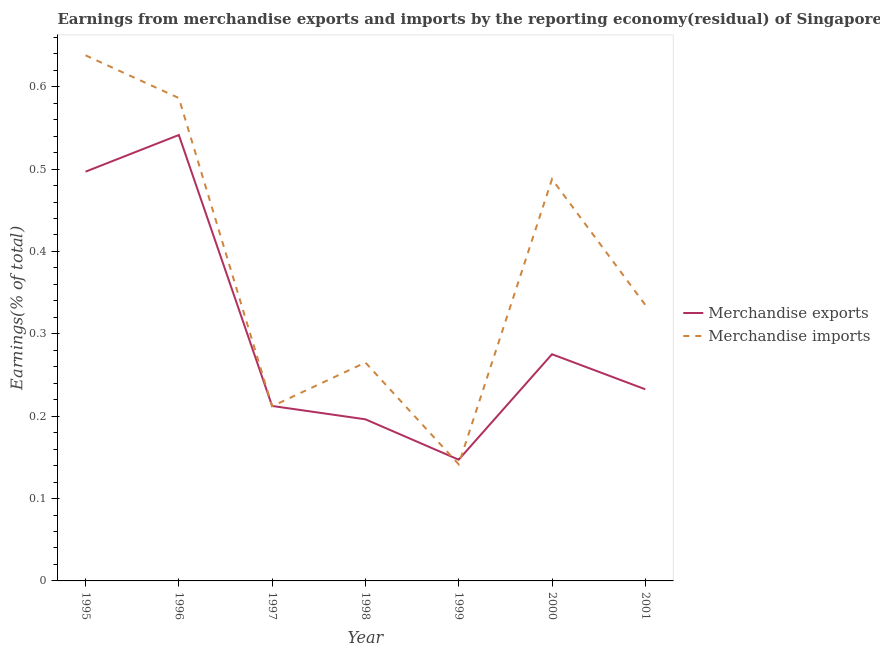How many different coloured lines are there?
Make the answer very short. 2. Does the line corresponding to earnings from merchandise imports intersect with the line corresponding to earnings from merchandise exports?
Give a very brief answer. Yes. Is the number of lines equal to the number of legend labels?
Keep it short and to the point. Yes. What is the earnings from merchandise imports in 2001?
Make the answer very short. 0.34. Across all years, what is the maximum earnings from merchandise exports?
Provide a short and direct response. 0.54. Across all years, what is the minimum earnings from merchandise imports?
Provide a short and direct response. 0.14. What is the total earnings from merchandise exports in the graph?
Make the answer very short. 2.1. What is the difference between the earnings from merchandise exports in 1998 and that in 2000?
Provide a succinct answer. -0.08. What is the difference between the earnings from merchandise exports in 1997 and the earnings from merchandise imports in 1996?
Provide a short and direct response. -0.37. What is the average earnings from merchandise exports per year?
Provide a succinct answer. 0.3. In the year 1996, what is the difference between the earnings from merchandise exports and earnings from merchandise imports?
Your answer should be very brief. -0.04. What is the ratio of the earnings from merchandise imports in 1996 to that in 2000?
Ensure brevity in your answer.  1.2. Is the difference between the earnings from merchandise exports in 1996 and 1998 greater than the difference between the earnings from merchandise imports in 1996 and 1998?
Your answer should be very brief. Yes. What is the difference between the highest and the second highest earnings from merchandise exports?
Provide a short and direct response. 0.04. What is the difference between the highest and the lowest earnings from merchandise imports?
Provide a short and direct response. 0.5. Is the sum of the earnings from merchandise imports in 1995 and 1997 greater than the maximum earnings from merchandise exports across all years?
Offer a terse response. Yes. Does the earnings from merchandise imports monotonically increase over the years?
Ensure brevity in your answer.  No. Is the earnings from merchandise exports strictly greater than the earnings from merchandise imports over the years?
Give a very brief answer. No. How many lines are there?
Give a very brief answer. 2. Are the values on the major ticks of Y-axis written in scientific E-notation?
Offer a terse response. No. Where does the legend appear in the graph?
Provide a short and direct response. Center right. How many legend labels are there?
Your answer should be compact. 2. How are the legend labels stacked?
Your response must be concise. Vertical. What is the title of the graph?
Give a very brief answer. Earnings from merchandise exports and imports by the reporting economy(residual) of Singapore. Does "From production" appear as one of the legend labels in the graph?
Keep it short and to the point. No. What is the label or title of the X-axis?
Your answer should be compact. Year. What is the label or title of the Y-axis?
Provide a succinct answer. Earnings(% of total). What is the Earnings(% of total) of Merchandise exports in 1995?
Offer a terse response. 0.5. What is the Earnings(% of total) in Merchandise imports in 1995?
Give a very brief answer. 0.64. What is the Earnings(% of total) in Merchandise exports in 1996?
Offer a terse response. 0.54. What is the Earnings(% of total) in Merchandise imports in 1996?
Offer a very short reply. 0.59. What is the Earnings(% of total) in Merchandise exports in 1997?
Keep it short and to the point. 0.21. What is the Earnings(% of total) in Merchandise imports in 1997?
Your answer should be compact. 0.21. What is the Earnings(% of total) in Merchandise exports in 1998?
Offer a very short reply. 0.2. What is the Earnings(% of total) in Merchandise imports in 1998?
Provide a short and direct response. 0.27. What is the Earnings(% of total) in Merchandise exports in 1999?
Your answer should be very brief. 0.15. What is the Earnings(% of total) in Merchandise imports in 1999?
Your response must be concise. 0.14. What is the Earnings(% of total) of Merchandise exports in 2000?
Keep it short and to the point. 0.28. What is the Earnings(% of total) in Merchandise imports in 2000?
Your response must be concise. 0.49. What is the Earnings(% of total) of Merchandise exports in 2001?
Offer a terse response. 0.23. What is the Earnings(% of total) of Merchandise imports in 2001?
Provide a short and direct response. 0.34. Across all years, what is the maximum Earnings(% of total) of Merchandise exports?
Ensure brevity in your answer.  0.54. Across all years, what is the maximum Earnings(% of total) in Merchandise imports?
Keep it short and to the point. 0.64. Across all years, what is the minimum Earnings(% of total) of Merchandise exports?
Offer a very short reply. 0.15. Across all years, what is the minimum Earnings(% of total) in Merchandise imports?
Ensure brevity in your answer.  0.14. What is the total Earnings(% of total) of Merchandise exports in the graph?
Provide a succinct answer. 2.1. What is the total Earnings(% of total) in Merchandise imports in the graph?
Ensure brevity in your answer.  2.67. What is the difference between the Earnings(% of total) of Merchandise exports in 1995 and that in 1996?
Keep it short and to the point. -0.04. What is the difference between the Earnings(% of total) in Merchandise imports in 1995 and that in 1996?
Ensure brevity in your answer.  0.05. What is the difference between the Earnings(% of total) of Merchandise exports in 1995 and that in 1997?
Offer a terse response. 0.28. What is the difference between the Earnings(% of total) in Merchandise imports in 1995 and that in 1997?
Keep it short and to the point. 0.43. What is the difference between the Earnings(% of total) in Merchandise exports in 1995 and that in 1998?
Your response must be concise. 0.3. What is the difference between the Earnings(% of total) of Merchandise imports in 1995 and that in 1998?
Make the answer very short. 0.37. What is the difference between the Earnings(% of total) of Merchandise exports in 1995 and that in 1999?
Give a very brief answer. 0.35. What is the difference between the Earnings(% of total) of Merchandise imports in 1995 and that in 1999?
Your answer should be compact. 0.5. What is the difference between the Earnings(% of total) in Merchandise exports in 1995 and that in 2000?
Your answer should be compact. 0.22. What is the difference between the Earnings(% of total) of Merchandise imports in 1995 and that in 2000?
Your response must be concise. 0.15. What is the difference between the Earnings(% of total) in Merchandise exports in 1995 and that in 2001?
Your response must be concise. 0.26. What is the difference between the Earnings(% of total) of Merchandise imports in 1995 and that in 2001?
Your answer should be compact. 0.3. What is the difference between the Earnings(% of total) of Merchandise exports in 1996 and that in 1997?
Keep it short and to the point. 0.33. What is the difference between the Earnings(% of total) of Merchandise imports in 1996 and that in 1997?
Your answer should be very brief. 0.37. What is the difference between the Earnings(% of total) of Merchandise exports in 1996 and that in 1998?
Offer a very short reply. 0.35. What is the difference between the Earnings(% of total) of Merchandise imports in 1996 and that in 1998?
Keep it short and to the point. 0.32. What is the difference between the Earnings(% of total) in Merchandise exports in 1996 and that in 1999?
Offer a terse response. 0.39. What is the difference between the Earnings(% of total) of Merchandise imports in 1996 and that in 1999?
Give a very brief answer. 0.44. What is the difference between the Earnings(% of total) of Merchandise exports in 1996 and that in 2000?
Your response must be concise. 0.27. What is the difference between the Earnings(% of total) of Merchandise imports in 1996 and that in 2000?
Your answer should be very brief. 0.1. What is the difference between the Earnings(% of total) in Merchandise exports in 1996 and that in 2001?
Give a very brief answer. 0.31. What is the difference between the Earnings(% of total) of Merchandise imports in 1996 and that in 2001?
Offer a very short reply. 0.25. What is the difference between the Earnings(% of total) in Merchandise exports in 1997 and that in 1998?
Your answer should be compact. 0.02. What is the difference between the Earnings(% of total) of Merchandise imports in 1997 and that in 1998?
Your answer should be very brief. -0.05. What is the difference between the Earnings(% of total) of Merchandise exports in 1997 and that in 1999?
Ensure brevity in your answer.  0.07. What is the difference between the Earnings(% of total) of Merchandise imports in 1997 and that in 1999?
Your answer should be compact. 0.07. What is the difference between the Earnings(% of total) of Merchandise exports in 1997 and that in 2000?
Make the answer very short. -0.06. What is the difference between the Earnings(% of total) in Merchandise imports in 1997 and that in 2000?
Your response must be concise. -0.28. What is the difference between the Earnings(% of total) in Merchandise exports in 1997 and that in 2001?
Keep it short and to the point. -0.02. What is the difference between the Earnings(% of total) of Merchandise imports in 1997 and that in 2001?
Offer a terse response. -0.12. What is the difference between the Earnings(% of total) of Merchandise exports in 1998 and that in 1999?
Make the answer very short. 0.05. What is the difference between the Earnings(% of total) of Merchandise imports in 1998 and that in 1999?
Offer a terse response. 0.12. What is the difference between the Earnings(% of total) of Merchandise exports in 1998 and that in 2000?
Offer a very short reply. -0.08. What is the difference between the Earnings(% of total) of Merchandise imports in 1998 and that in 2000?
Offer a very short reply. -0.22. What is the difference between the Earnings(% of total) in Merchandise exports in 1998 and that in 2001?
Make the answer very short. -0.04. What is the difference between the Earnings(% of total) of Merchandise imports in 1998 and that in 2001?
Give a very brief answer. -0.07. What is the difference between the Earnings(% of total) in Merchandise exports in 1999 and that in 2000?
Ensure brevity in your answer.  -0.13. What is the difference between the Earnings(% of total) in Merchandise imports in 1999 and that in 2000?
Make the answer very short. -0.35. What is the difference between the Earnings(% of total) of Merchandise exports in 1999 and that in 2001?
Your answer should be very brief. -0.09. What is the difference between the Earnings(% of total) of Merchandise imports in 1999 and that in 2001?
Provide a short and direct response. -0.19. What is the difference between the Earnings(% of total) in Merchandise exports in 2000 and that in 2001?
Offer a terse response. 0.04. What is the difference between the Earnings(% of total) of Merchandise imports in 2000 and that in 2001?
Keep it short and to the point. 0.15. What is the difference between the Earnings(% of total) of Merchandise exports in 1995 and the Earnings(% of total) of Merchandise imports in 1996?
Your response must be concise. -0.09. What is the difference between the Earnings(% of total) in Merchandise exports in 1995 and the Earnings(% of total) in Merchandise imports in 1997?
Offer a very short reply. 0.28. What is the difference between the Earnings(% of total) of Merchandise exports in 1995 and the Earnings(% of total) of Merchandise imports in 1998?
Your response must be concise. 0.23. What is the difference between the Earnings(% of total) in Merchandise exports in 1995 and the Earnings(% of total) in Merchandise imports in 1999?
Ensure brevity in your answer.  0.36. What is the difference between the Earnings(% of total) in Merchandise exports in 1995 and the Earnings(% of total) in Merchandise imports in 2000?
Your response must be concise. 0.01. What is the difference between the Earnings(% of total) of Merchandise exports in 1995 and the Earnings(% of total) of Merchandise imports in 2001?
Your response must be concise. 0.16. What is the difference between the Earnings(% of total) of Merchandise exports in 1996 and the Earnings(% of total) of Merchandise imports in 1997?
Provide a succinct answer. 0.33. What is the difference between the Earnings(% of total) of Merchandise exports in 1996 and the Earnings(% of total) of Merchandise imports in 1998?
Your answer should be very brief. 0.28. What is the difference between the Earnings(% of total) of Merchandise exports in 1996 and the Earnings(% of total) of Merchandise imports in 1999?
Offer a terse response. 0.4. What is the difference between the Earnings(% of total) in Merchandise exports in 1996 and the Earnings(% of total) in Merchandise imports in 2000?
Your answer should be very brief. 0.05. What is the difference between the Earnings(% of total) in Merchandise exports in 1996 and the Earnings(% of total) in Merchandise imports in 2001?
Your answer should be very brief. 0.21. What is the difference between the Earnings(% of total) in Merchandise exports in 1997 and the Earnings(% of total) in Merchandise imports in 1998?
Your answer should be compact. -0.05. What is the difference between the Earnings(% of total) in Merchandise exports in 1997 and the Earnings(% of total) in Merchandise imports in 1999?
Provide a short and direct response. 0.07. What is the difference between the Earnings(% of total) of Merchandise exports in 1997 and the Earnings(% of total) of Merchandise imports in 2000?
Make the answer very short. -0.28. What is the difference between the Earnings(% of total) of Merchandise exports in 1997 and the Earnings(% of total) of Merchandise imports in 2001?
Ensure brevity in your answer.  -0.12. What is the difference between the Earnings(% of total) in Merchandise exports in 1998 and the Earnings(% of total) in Merchandise imports in 1999?
Provide a short and direct response. 0.05. What is the difference between the Earnings(% of total) in Merchandise exports in 1998 and the Earnings(% of total) in Merchandise imports in 2000?
Offer a very short reply. -0.29. What is the difference between the Earnings(% of total) of Merchandise exports in 1998 and the Earnings(% of total) of Merchandise imports in 2001?
Offer a very short reply. -0.14. What is the difference between the Earnings(% of total) of Merchandise exports in 1999 and the Earnings(% of total) of Merchandise imports in 2000?
Provide a succinct answer. -0.34. What is the difference between the Earnings(% of total) in Merchandise exports in 1999 and the Earnings(% of total) in Merchandise imports in 2001?
Offer a terse response. -0.19. What is the difference between the Earnings(% of total) of Merchandise exports in 2000 and the Earnings(% of total) of Merchandise imports in 2001?
Your response must be concise. -0.06. What is the average Earnings(% of total) in Merchandise exports per year?
Provide a short and direct response. 0.3. What is the average Earnings(% of total) in Merchandise imports per year?
Ensure brevity in your answer.  0.38. In the year 1995, what is the difference between the Earnings(% of total) of Merchandise exports and Earnings(% of total) of Merchandise imports?
Ensure brevity in your answer.  -0.14. In the year 1996, what is the difference between the Earnings(% of total) of Merchandise exports and Earnings(% of total) of Merchandise imports?
Offer a terse response. -0.04. In the year 1997, what is the difference between the Earnings(% of total) in Merchandise exports and Earnings(% of total) in Merchandise imports?
Offer a very short reply. 0. In the year 1998, what is the difference between the Earnings(% of total) in Merchandise exports and Earnings(% of total) in Merchandise imports?
Give a very brief answer. -0.07. In the year 1999, what is the difference between the Earnings(% of total) of Merchandise exports and Earnings(% of total) of Merchandise imports?
Your response must be concise. 0.01. In the year 2000, what is the difference between the Earnings(% of total) in Merchandise exports and Earnings(% of total) in Merchandise imports?
Your response must be concise. -0.21. In the year 2001, what is the difference between the Earnings(% of total) of Merchandise exports and Earnings(% of total) of Merchandise imports?
Make the answer very short. -0.1. What is the ratio of the Earnings(% of total) in Merchandise exports in 1995 to that in 1996?
Make the answer very short. 0.92. What is the ratio of the Earnings(% of total) in Merchandise imports in 1995 to that in 1996?
Your answer should be compact. 1.09. What is the ratio of the Earnings(% of total) of Merchandise exports in 1995 to that in 1997?
Your answer should be very brief. 2.34. What is the ratio of the Earnings(% of total) in Merchandise imports in 1995 to that in 1997?
Offer a terse response. 3.01. What is the ratio of the Earnings(% of total) in Merchandise exports in 1995 to that in 1998?
Your answer should be very brief. 2.53. What is the ratio of the Earnings(% of total) of Merchandise imports in 1995 to that in 1998?
Provide a succinct answer. 2.41. What is the ratio of the Earnings(% of total) of Merchandise exports in 1995 to that in 1999?
Offer a very short reply. 3.38. What is the ratio of the Earnings(% of total) of Merchandise imports in 1995 to that in 1999?
Provide a succinct answer. 4.51. What is the ratio of the Earnings(% of total) of Merchandise exports in 1995 to that in 2000?
Make the answer very short. 1.81. What is the ratio of the Earnings(% of total) of Merchandise imports in 1995 to that in 2000?
Ensure brevity in your answer.  1.31. What is the ratio of the Earnings(% of total) of Merchandise exports in 1995 to that in 2001?
Offer a terse response. 2.14. What is the ratio of the Earnings(% of total) in Merchandise imports in 1995 to that in 2001?
Ensure brevity in your answer.  1.9. What is the ratio of the Earnings(% of total) of Merchandise exports in 1996 to that in 1997?
Give a very brief answer. 2.55. What is the ratio of the Earnings(% of total) of Merchandise imports in 1996 to that in 1997?
Make the answer very short. 2.76. What is the ratio of the Earnings(% of total) of Merchandise exports in 1996 to that in 1998?
Give a very brief answer. 2.76. What is the ratio of the Earnings(% of total) of Merchandise imports in 1996 to that in 1998?
Offer a terse response. 2.21. What is the ratio of the Earnings(% of total) of Merchandise exports in 1996 to that in 1999?
Your response must be concise. 3.68. What is the ratio of the Earnings(% of total) of Merchandise imports in 1996 to that in 1999?
Provide a succinct answer. 4.14. What is the ratio of the Earnings(% of total) in Merchandise exports in 1996 to that in 2000?
Your answer should be very brief. 1.97. What is the ratio of the Earnings(% of total) of Merchandise imports in 1996 to that in 2000?
Give a very brief answer. 1.2. What is the ratio of the Earnings(% of total) of Merchandise exports in 1996 to that in 2001?
Offer a very short reply. 2.33. What is the ratio of the Earnings(% of total) in Merchandise imports in 1996 to that in 2001?
Your response must be concise. 1.75. What is the ratio of the Earnings(% of total) of Merchandise exports in 1997 to that in 1998?
Provide a succinct answer. 1.08. What is the ratio of the Earnings(% of total) in Merchandise imports in 1997 to that in 1998?
Keep it short and to the point. 0.8. What is the ratio of the Earnings(% of total) in Merchandise exports in 1997 to that in 1999?
Make the answer very short. 1.44. What is the ratio of the Earnings(% of total) of Merchandise imports in 1997 to that in 1999?
Keep it short and to the point. 1.5. What is the ratio of the Earnings(% of total) in Merchandise exports in 1997 to that in 2000?
Provide a succinct answer. 0.77. What is the ratio of the Earnings(% of total) in Merchandise imports in 1997 to that in 2000?
Keep it short and to the point. 0.43. What is the ratio of the Earnings(% of total) of Merchandise exports in 1997 to that in 2001?
Keep it short and to the point. 0.91. What is the ratio of the Earnings(% of total) in Merchandise imports in 1997 to that in 2001?
Offer a terse response. 0.63. What is the ratio of the Earnings(% of total) in Merchandise exports in 1998 to that in 1999?
Offer a very short reply. 1.33. What is the ratio of the Earnings(% of total) in Merchandise imports in 1998 to that in 1999?
Provide a succinct answer. 1.87. What is the ratio of the Earnings(% of total) in Merchandise exports in 1998 to that in 2000?
Provide a short and direct response. 0.71. What is the ratio of the Earnings(% of total) of Merchandise imports in 1998 to that in 2000?
Give a very brief answer. 0.54. What is the ratio of the Earnings(% of total) of Merchandise exports in 1998 to that in 2001?
Your answer should be compact. 0.84. What is the ratio of the Earnings(% of total) in Merchandise imports in 1998 to that in 2001?
Make the answer very short. 0.79. What is the ratio of the Earnings(% of total) of Merchandise exports in 1999 to that in 2000?
Make the answer very short. 0.53. What is the ratio of the Earnings(% of total) of Merchandise imports in 1999 to that in 2000?
Give a very brief answer. 0.29. What is the ratio of the Earnings(% of total) in Merchandise exports in 1999 to that in 2001?
Ensure brevity in your answer.  0.63. What is the ratio of the Earnings(% of total) in Merchandise imports in 1999 to that in 2001?
Ensure brevity in your answer.  0.42. What is the ratio of the Earnings(% of total) of Merchandise exports in 2000 to that in 2001?
Give a very brief answer. 1.18. What is the ratio of the Earnings(% of total) in Merchandise imports in 2000 to that in 2001?
Provide a succinct answer. 1.46. What is the difference between the highest and the second highest Earnings(% of total) in Merchandise exports?
Keep it short and to the point. 0.04. What is the difference between the highest and the second highest Earnings(% of total) in Merchandise imports?
Your answer should be compact. 0.05. What is the difference between the highest and the lowest Earnings(% of total) in Merchandise exports?
Your response must be concise. 0.39. What is the difference between the highest and the lowest Earnings(% of total) in Merchandise imports?
Ensure brevity in your answer.  0.5. 